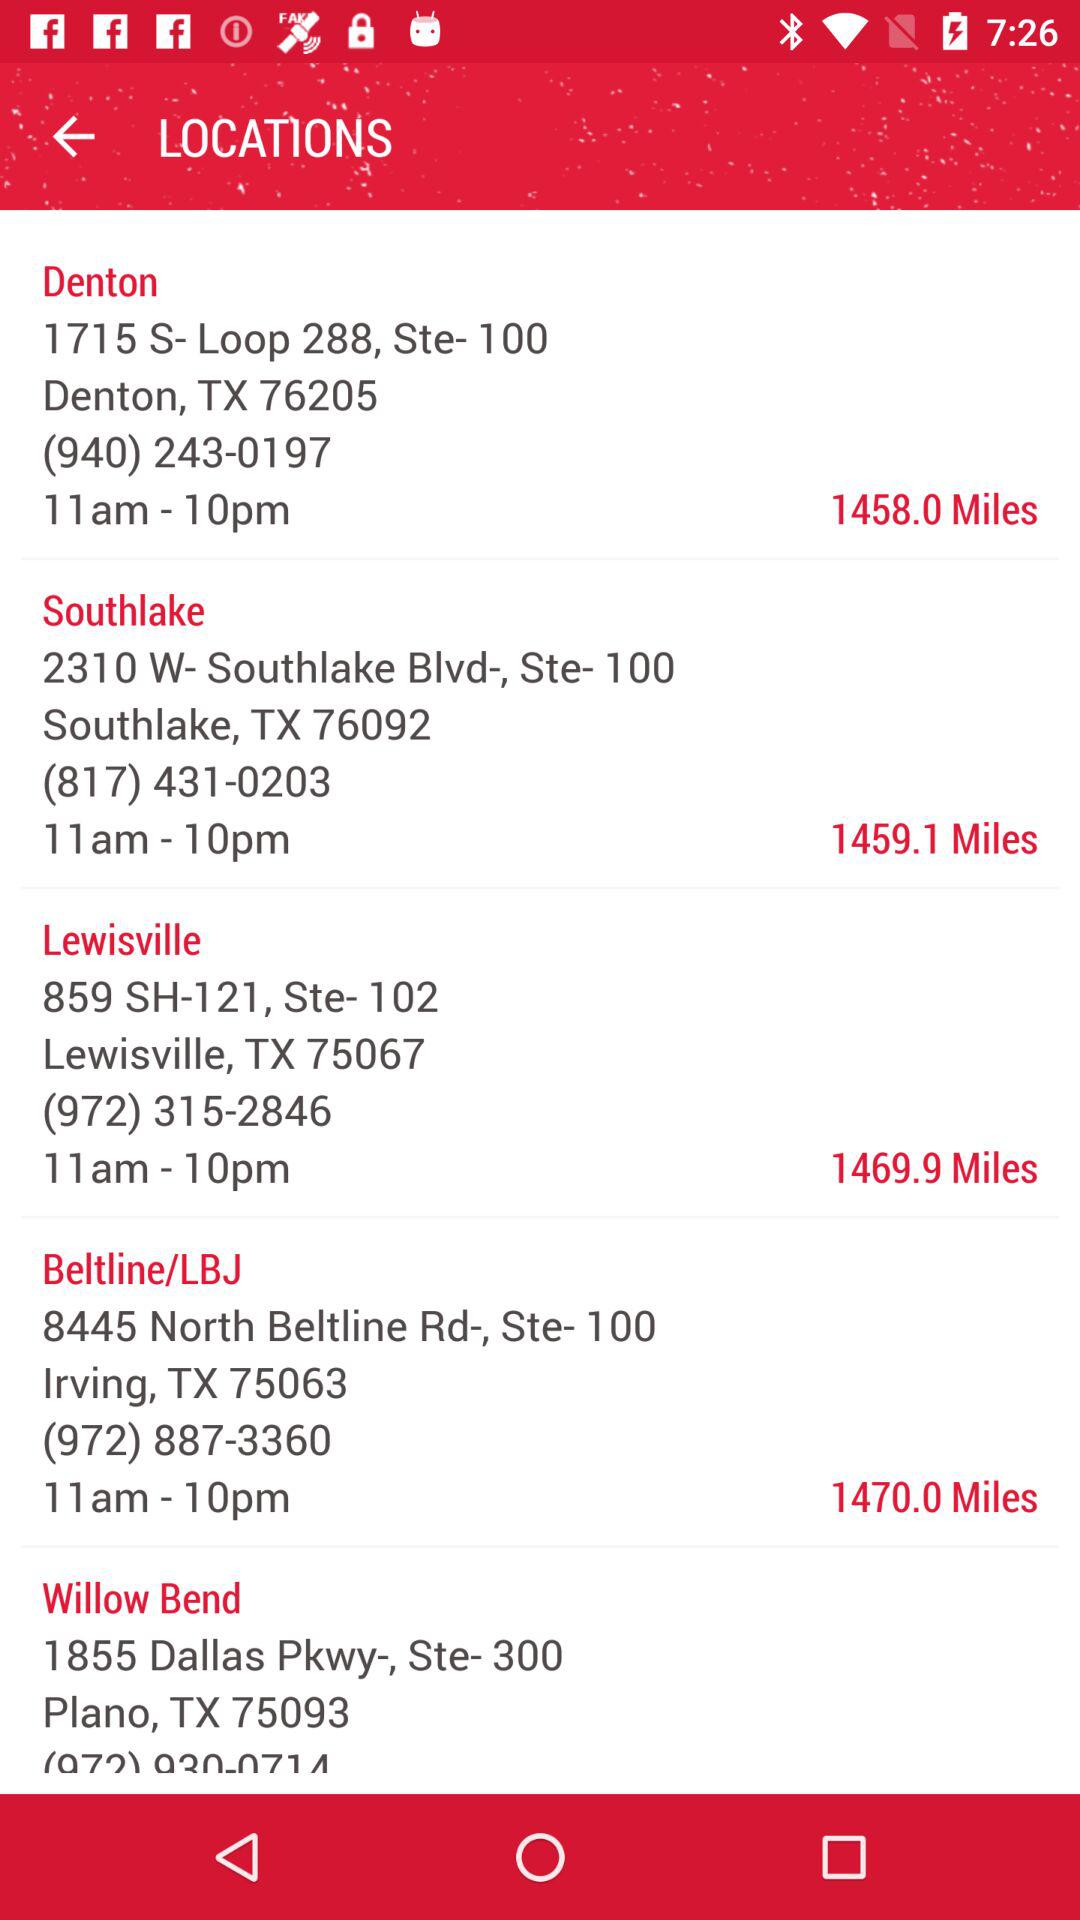What is the location of Lewisville? The location is 859 SH-121, Ste-102, Lewisville,TX 75067. 